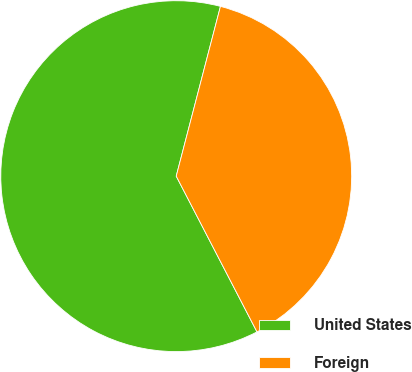Convert chart. <chart><loc_0><loc_0><loc_500><loc_500><pie_chart><fcel>United States<fcel>Foreign<nl><fcel>61.67%<fcel>38.33%<nl></chart> 